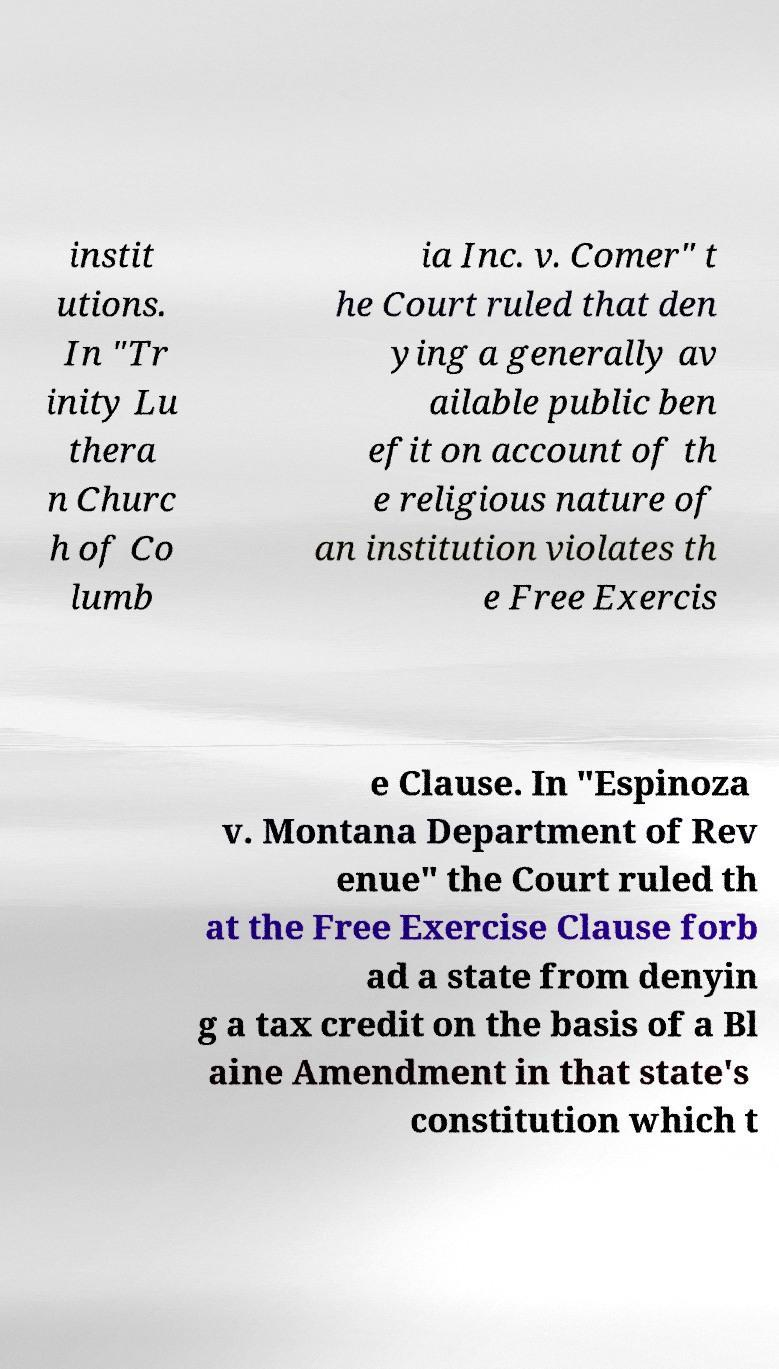Please identify and transcribe the text found in this image. instit utions. In "Tr inity Lu thera n Churc h of Co lumb ia Inc. v. Comer" t he Court ruled that den ying a generally av ailable public ben efit on account of th e religious nature of an institution violates th e Free Exercis e Clause. In "Espinoza v. Montana Department of Rev enue" the Court ruled th at the Free Exercise Clause forb ad a state from denyin g a tax credit on the basis of a Bl aine Amendment in that state's constitution which t 